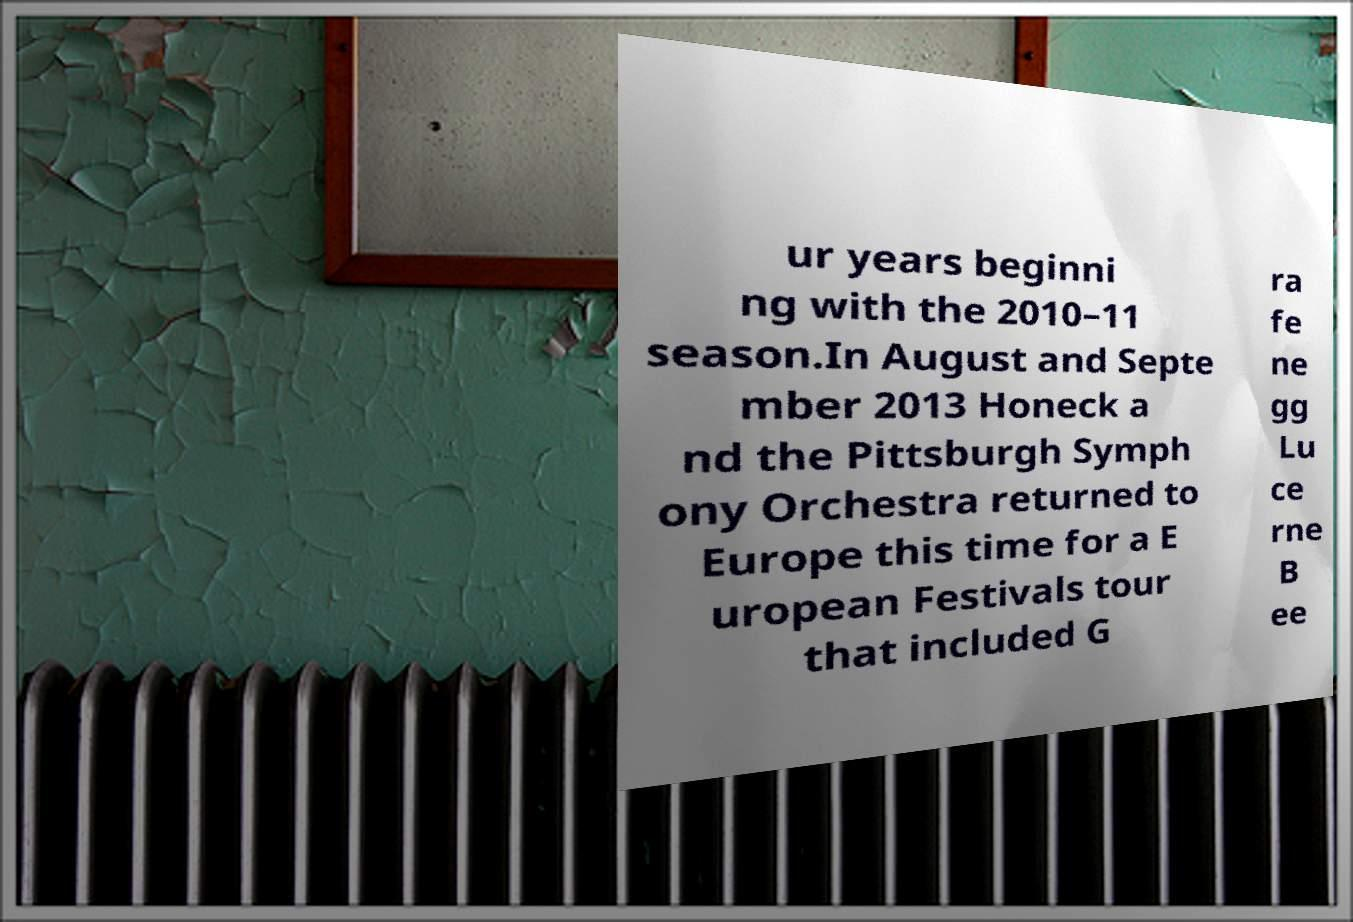I need the written content from this picture converted into text. Can you do that? ur years beginni ng with the 2010–11 season.In August and Septe mber 2013 Honeck a nd the Pittsburgh Symph ony Orchestra returned to Europe this time for a E uropean Festivals tour that included G ra fe ne gg Lu ce rne B ee 